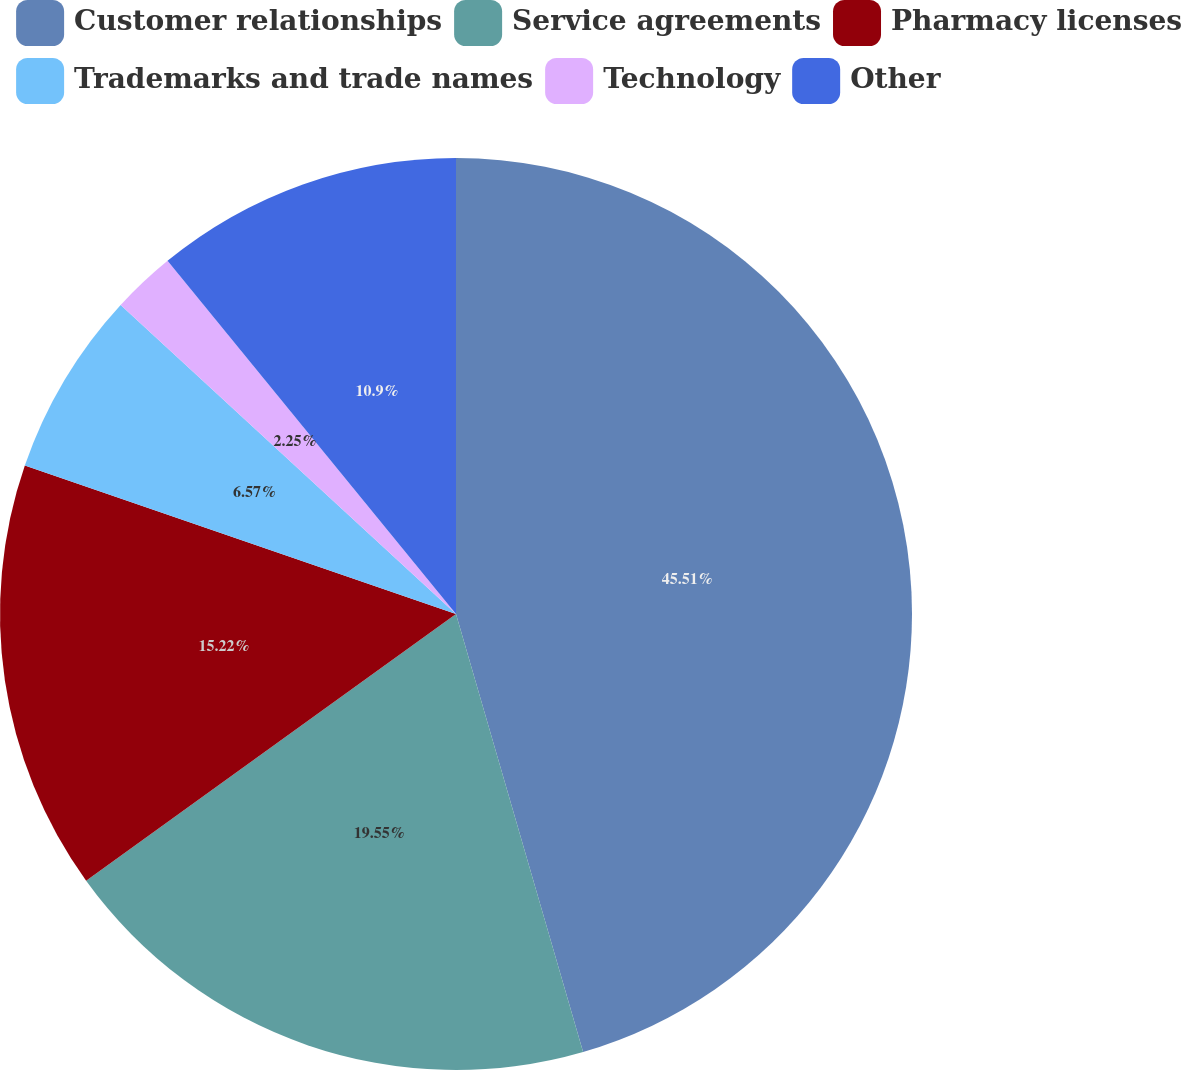Convert chart to OTSL. <chart><loc_0><loc_0><loc_500><loc_500><pie_chart><fcel>Customer relationships<fcel>Service agreements<fcel>Pharmacy licenses<fcel>Trademarks and trade names<fcel>Technology<fcel>Other<nl><fcel>45.5%<fcel>19.55%<fcel>15.22%<fcel>6.57%<fcel>2.25%<fcel>10.9%<nl></chart> 